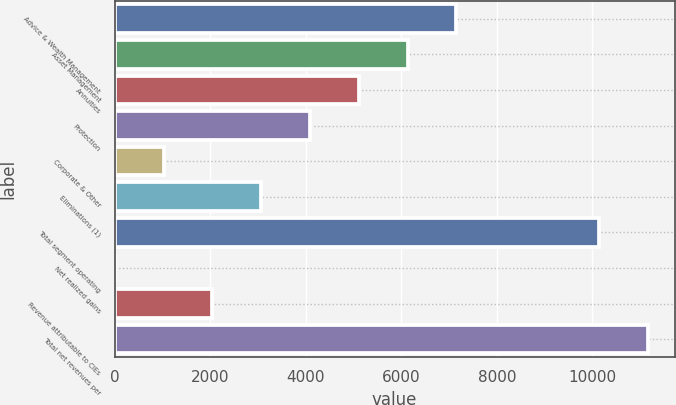Convert chart to OTSL. <chart><loc_0><loc_0><loc_500><loc_500><bar_chart><fcel>Advice & Wealth Management<fcel>Asset Management<fcel>Annuities<fcel>Protection<fcel>Corporate & Other<fcel>Eliminations (1)<fcel>Total segment operating<fcel>Net realized gains<fcel>Revenue attributable to CIEs<fcel>Total net revenues per<nl><fcel>7154<fcel>6133<fcel>5112<fcel>4091<fcel>1028<fcel>3070<fcel>10143<fcel>7<fcel>2049<fcel>11164<nl></chart> 